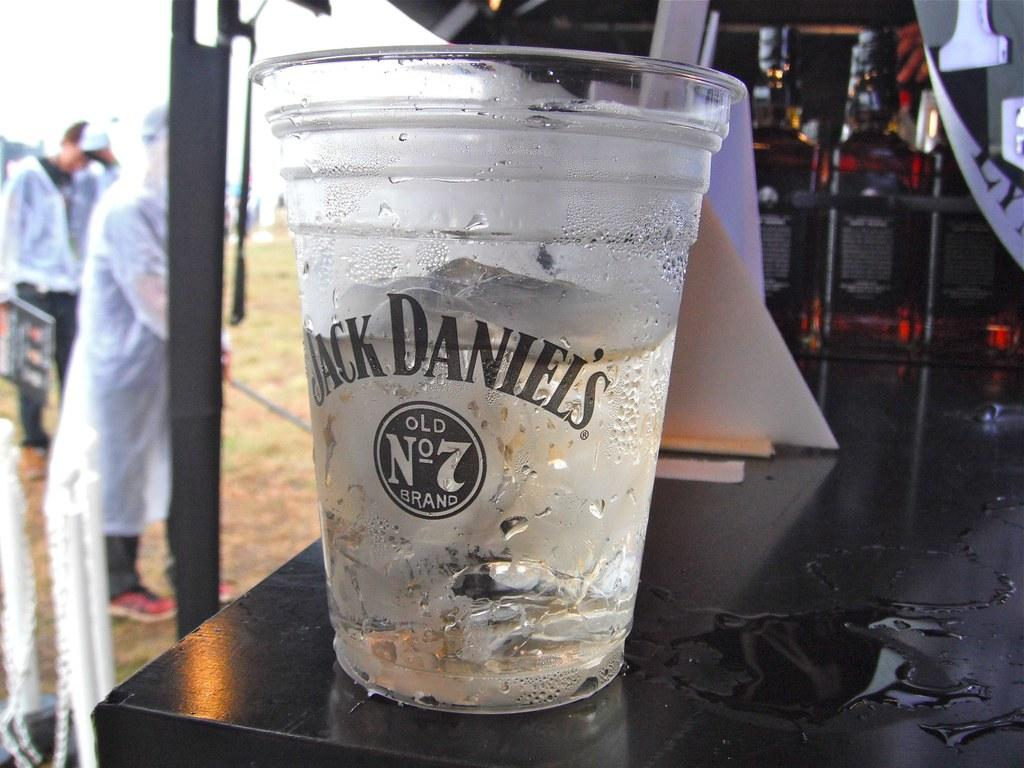What is located in the middle of the image? There is a glass in the middle of the image. Who or what is on the left side of the image? There are two persons on the left side of the image. What are the persons wearing on their upper bodies? The persons are wearing coats. What type of footwear are the persons wearing? The persons are wearing shoes. What type of basket can be seen in the image? There is no basket present in the image. Who is the daughter of the persons in the image? The provided facts do not mention any children or family relationships, so it is not possible to determine who the daughter might be. 